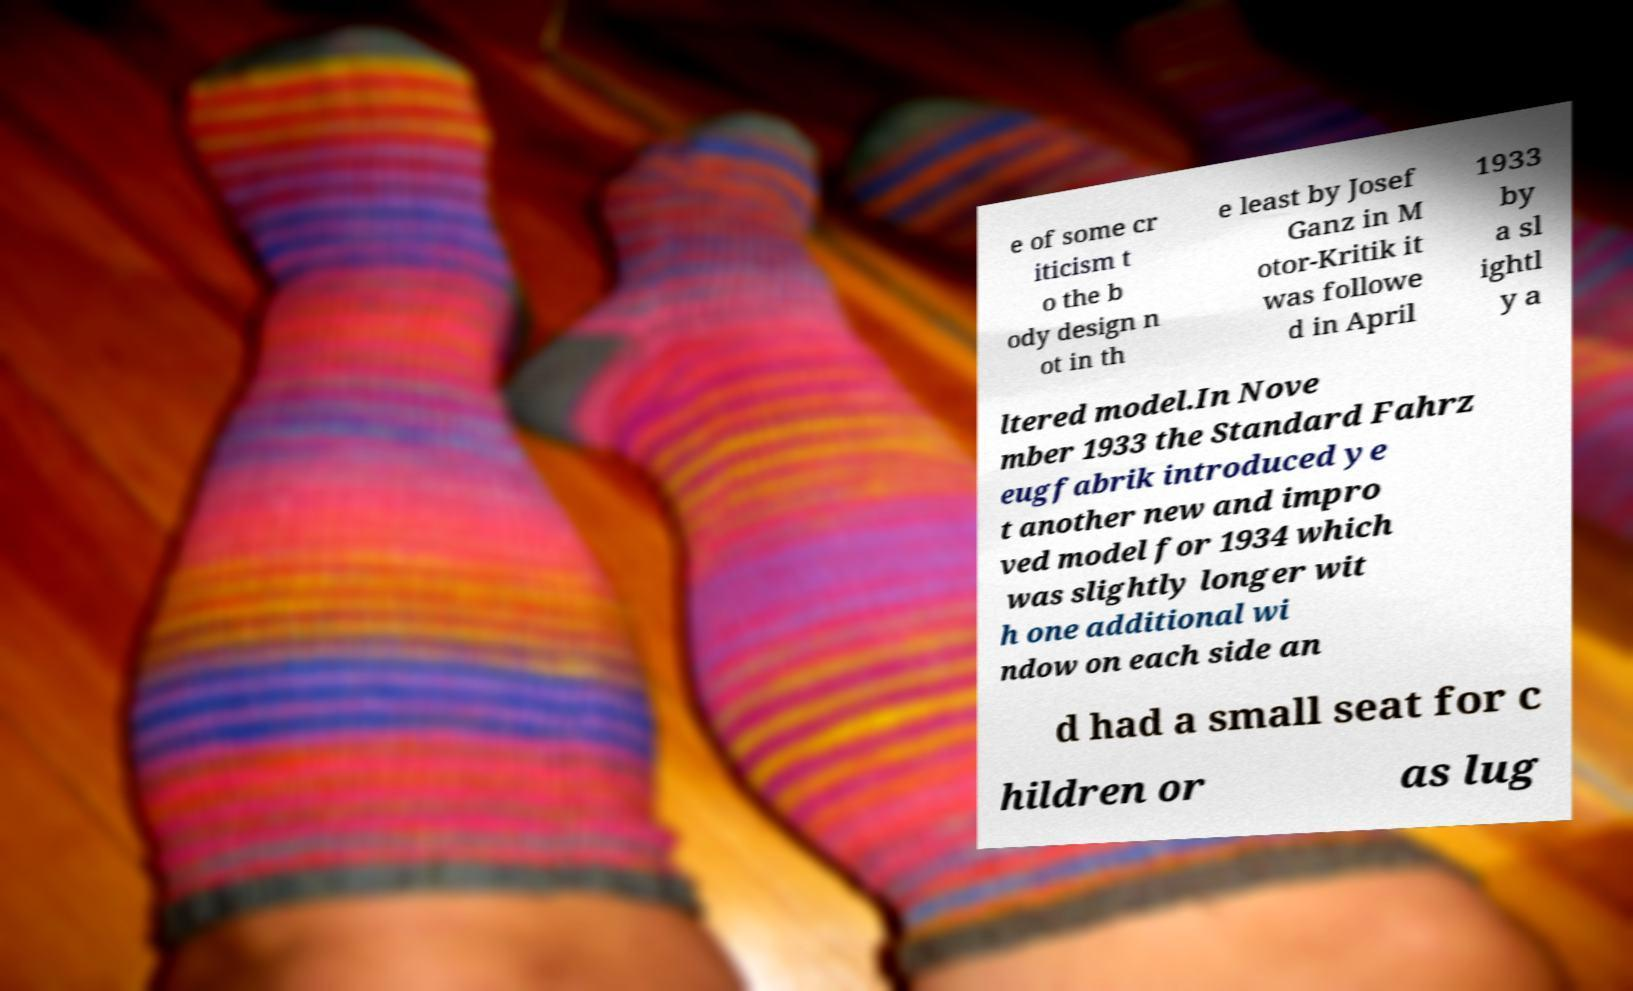Can you read and provide the text displayed in the image?This photo seems to have some interesting text. Can you extract and type it out for me? e of some cr iticism t o the b ody design n ot in th e least by Josef Ganz in M otor-Kritik it was followe d in April 1933 by a sl ightl y a ltered model.In Nove mber 1933 the Standard Fahrz eugfabrik introduced ye t another new and impro ved model for 1934 which was slightly longer wit h one additional wi ndow on each side an d had a small seat for c hildren or as lug 